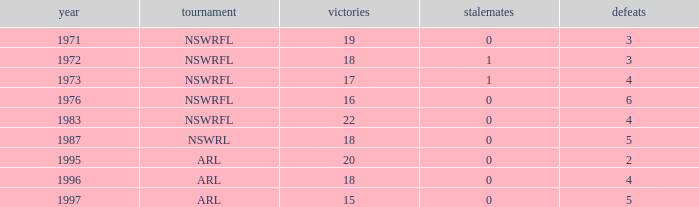What highest Year has Wins 15 and Losses less than 5? None. 